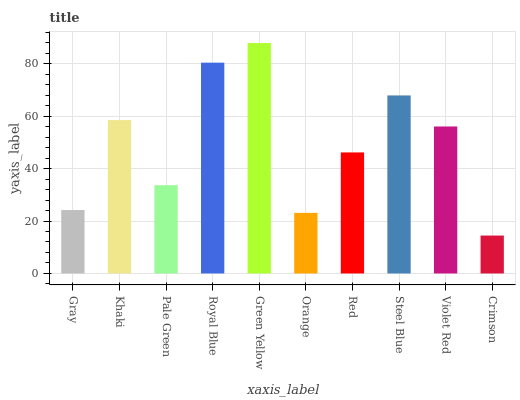Is Crimson the minimum?
Answer yes or no. Yes. Is Green Yellow the maximum?
Answer yes or no. Yes. Is Khaki the minimum?
Answer yes or no. No. Is Khaki the maximum?
Answer yes or no. No. Is Khaki greater than Gray?
Answer yes or no. Yes. Is Gray less than Khaki?
Answer yes or no. Yes. Is Gray greater than Khaki?
Answer yes or no. No. Is Khaki less than Gray?
Answer yes or no. No. Is Violet Red the high median?
Answer yes or no. Yes. Is Red the low median?
Answer yes or no. Yes. Is Red the high median?
Answer yes or no. No. Is Orange the low median?
Answer yes or no. No. 